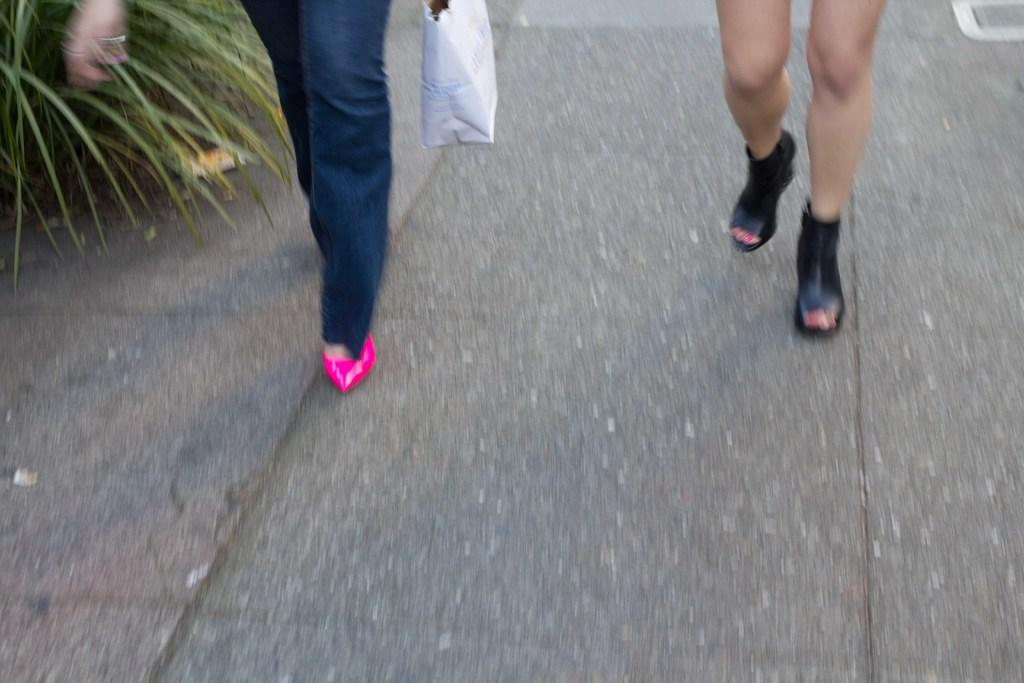What is the primary surface visible in the image? There is a floor in the image. What are the two persons in the image doing? The two persons in the image are walking. Where is the green color plant located in the image? The green color plant is on the left side of the image. What type of bubble is floating above the plant in the image? There is no bubble present in the image; it only features a floor, two persons walking, and a green color plant on the left side. 